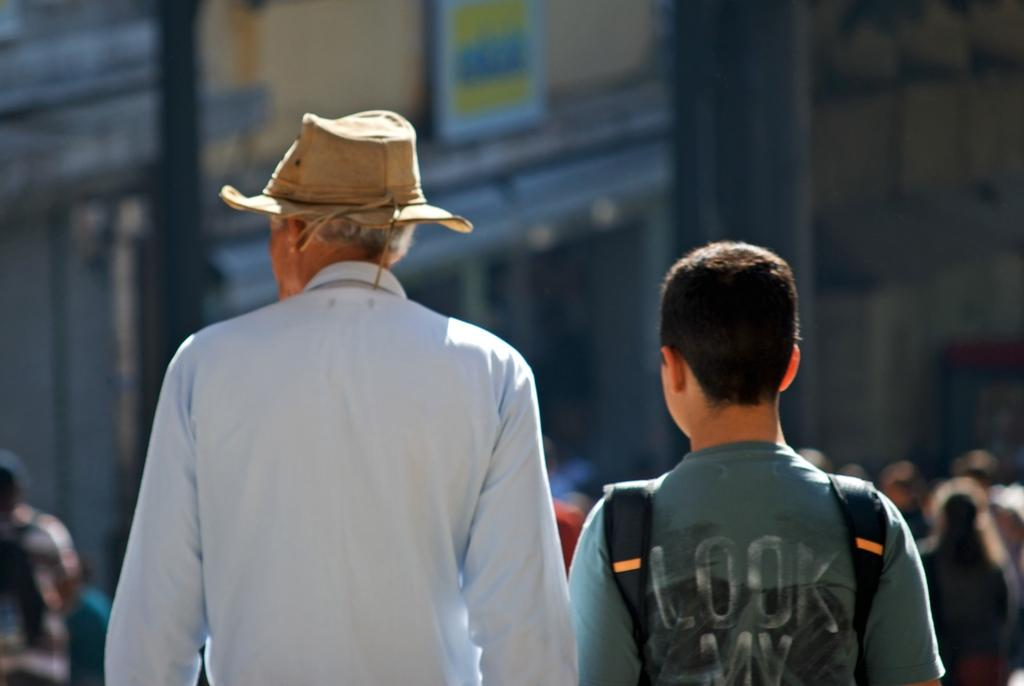What is the person on the left side of the image wearing? The person on the left side of the image is wearing a blue color shirt. What type of headwear is the person on the left side of the image wearing? The person on the left side of the image is wearing a cap. What is the boy on the right side of the image wearing? The boy on the right side of the image is wearing a T-shirt. Can you describe the background of the image? There are persons and buildings in the background of the image. What type of meat is being cooked on the metal grill in the image? There is no mention of a grill or meat in the image; it only features a person, a boy, and the background. 